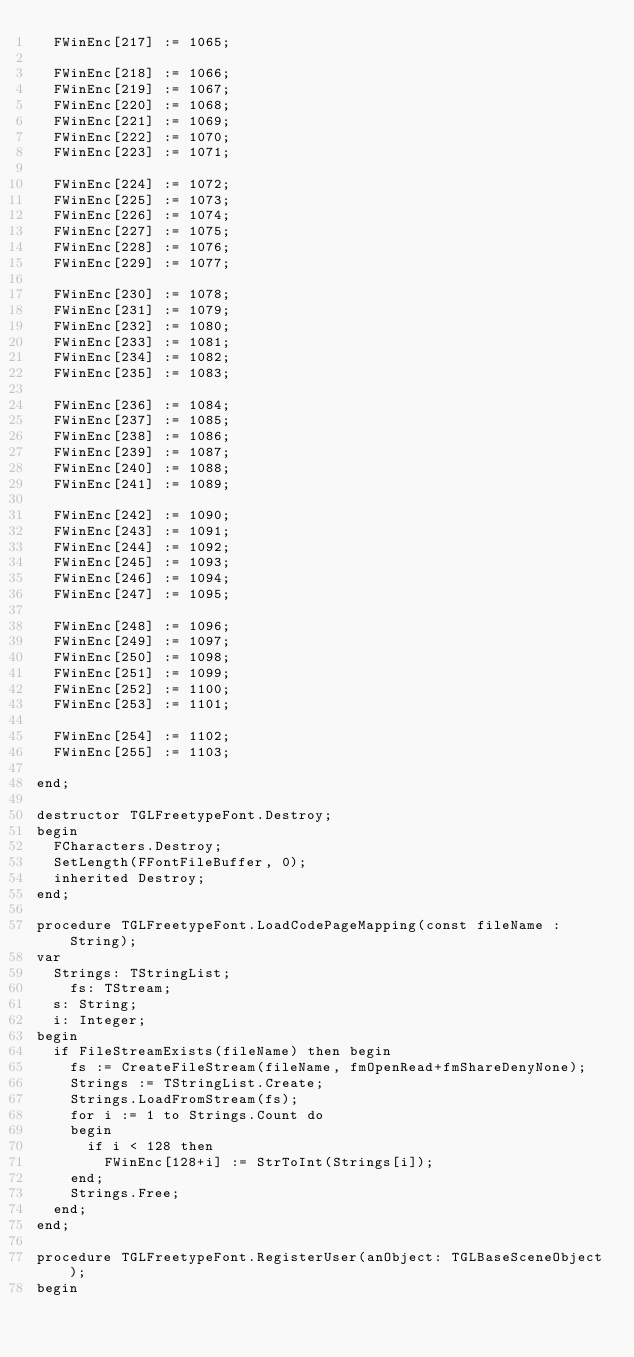Convert code to text. <code><loc_0><loc_0><loc_500><loc_500><_Pascal_>  FWinEnc[217] := 1065;

  FWinEnc[218] := 1066;
  FWinEnc[219] := 1067;
  FWinEnc[220] := 1068;
  FWinEnc[221] := 1069;
  FWinEnc[222] := 1070;
  FWinEnc[223] := 1071;

  FWinEnc[224] := 1072;
  FWinEnc[225] := 1073;
  FWinEnc[226] := 1074;
  FWinEnc[227] := 1075;
  FWinEnc[228] := 1076;
  FWinEnc[229] := 1077;

  FWinEnc[230] := 1078;
  FWinEnc[231] := 1079;
  FWinEnc[232] := 1080;
  FWinEnc[233] := 1081;
  FWinEnc[234] := 1082;
  FWinEnc[235] := 1083;

  FWinEnc[236] := 1084;
  FWinEnc[237] := 1085;
  FWinEnc[238] := 1086;
  FWinEnc[239] := 1087;
  FWinEnc[240] := 1088;
  FWinEnc[241] := 1089;

  FWinEnc[242] := 1090;
  FWinEnc[243] := 1091;
  FWinEnc[244] := 1092;
  FWinEnc[245] := 1093;
  FWinEnc[246] := 1094;
  FWinEnc[247] := 1095;

  FWinEnc[248] := 1096;
  FWinEnc[249] := 1097;
  FWinEnc[250] := 1098;
  FWinEnc[251] := 1099;
  FWinEnc[252] := 1100;
  FWinEnc[253] := 1101;

  FWinEnc[254] := 1102;
  FWinEnc[255] := 1103;

end;

destructor TGLFreetypeFont.Destroy;
begin
  FCharacters.Destroy;
  SetLength(FFontFileBuffer, 0);
  inherited Destroy;
end;

procedure TGLFreetypeFont.LoadCodePageMapping(const fileName : String);
var
  Strings: TStringList;
	fs: TStream;
  s: String;
  i: Integer;
begin
  if FileStreamExists(fileName) then begin
   	fs := CreateFileStream(fileName, fmOpenRead+fmShareDenyNone);
    Strings := TStringList.Create;
    Strings.LoadFromStream(fs);
    for i := 1 to Strings.Count do
    begin
      if i < 128 then
        FWinEnc[128+i] := StrToInt(Strings[i]);  
    end;
    Strings.Free;
  end;
end;

procedure TGLFreetypeFont.RegisterUser(anObject: TGLBaseSceneObject);
begin</code> 